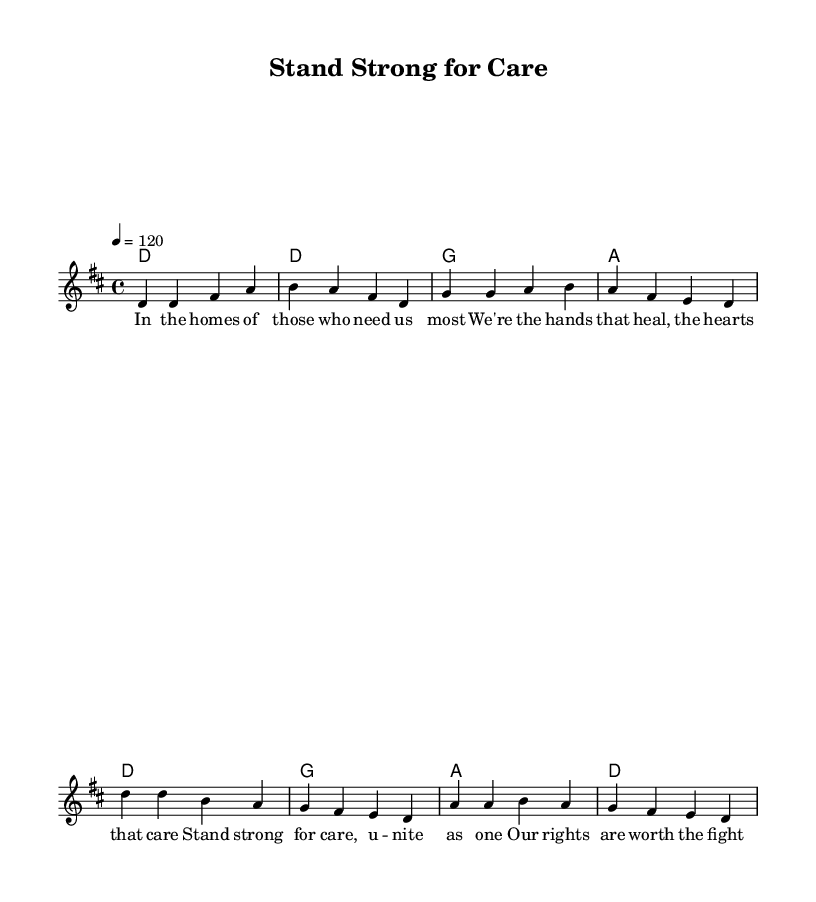What is the key signature of this music? The key signature is D major, indicated by the sharp sign which denotes F# and C#.
Answer: D major What is the time signature of this piece? The time signature is 4/4, which is shown at the start of the music and indicates four beats per measure.
Answer: 4/4 What is the tempo marking for this song? The tempo marking is 120 beats per minute, indicated in the score as "4 = 120".
Answer: 120 How many measures are in the verse section? The verse section consists of four measures, which can be counted in the melody part of the score.
Answer: Four How many chords are used in the chorus? The chorus uses three distinct chords: D, G, and A, as listed under the chord names for that section.
Answer: Three What lyrical theme is addressed in this song? The lyrics focus on the theme of solidarity and fighting for rights, evident in the phrases about standing strong and uniting.
Answer: Solidarity What is the main message conveyed through the lyrics? The main message is about the importance of caring work and the necessity of fighting for rights, which is found in the phrases of the chorus.
Answer: Fight for rights 